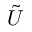<formula> <loc_0><loc_0><loc_500><loc_500>\tilde { U }</formula> 